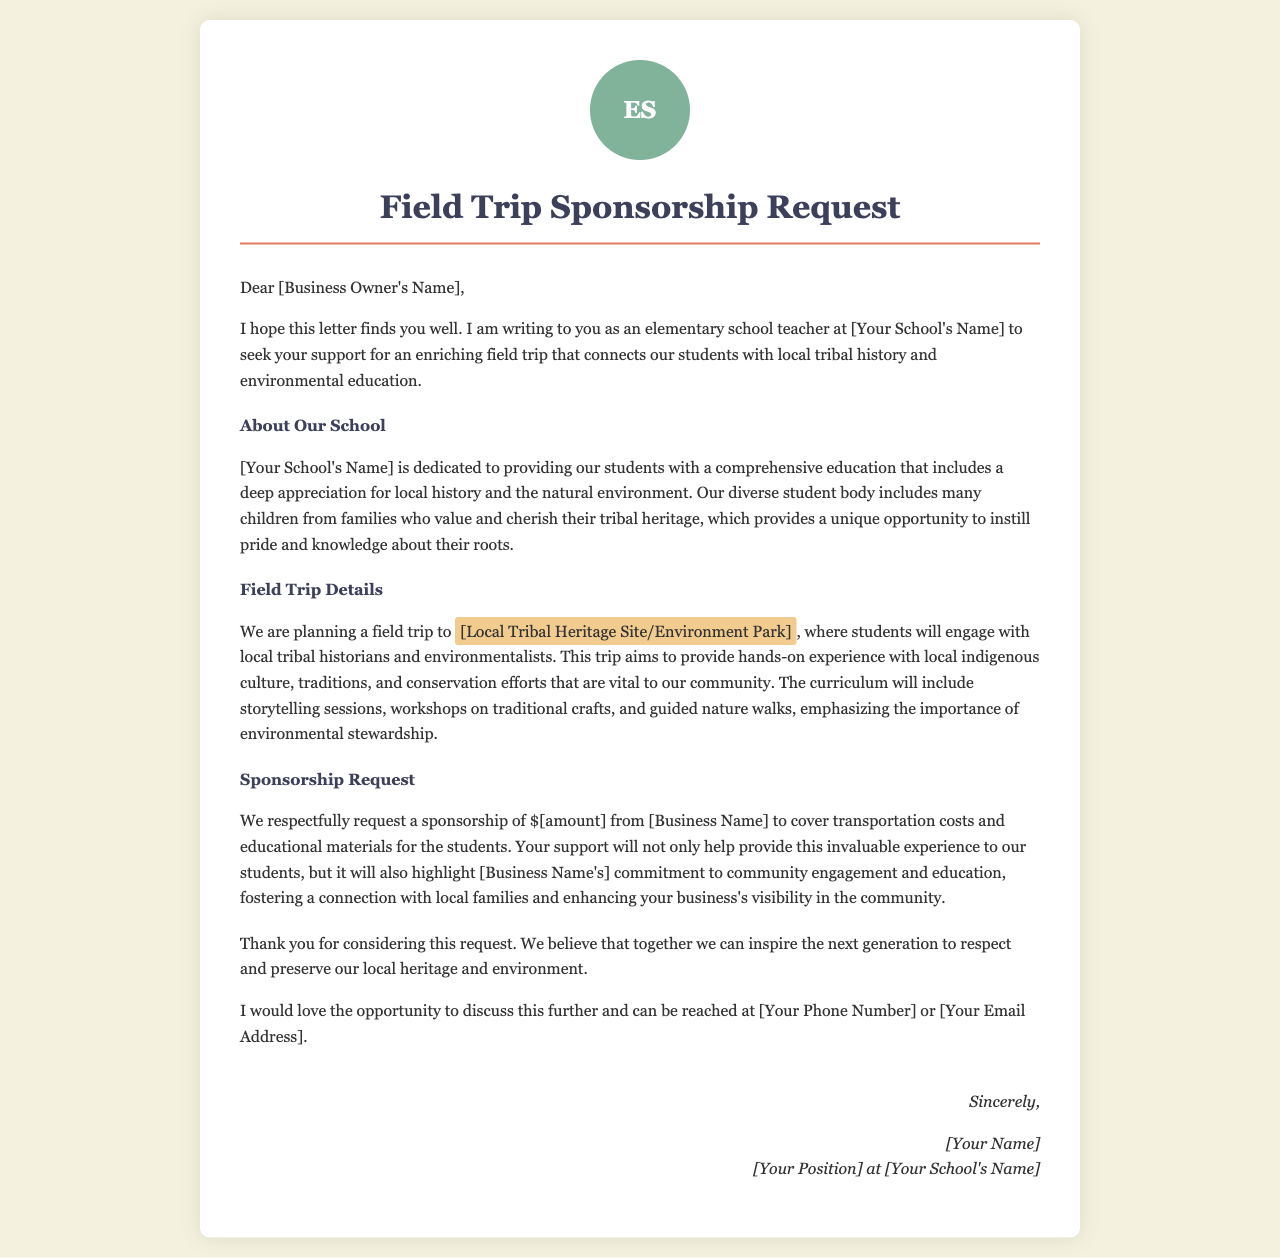what is the name of the school? The school mentioned in the document is referred to as [Your School's Name], which represents a placeholder for the actual name.
Answer: [Your School's Name] who is the letter addressed to? The letter is addressed to [Business Owner's Name], which is a placeholder for the actual name of the business owner.
Answer: [Business Owner's Name] what is the purpose of the field trip? The purpose of the field trip is to connect students with local tribal history and environmental education.
Answer: local tribal history and environmental education where will the field trip take place? The field trip will take place at [Local Tribal Heritage Site/Environment Park], which serves as a placeholder for the actual location.
Answer: [Local Tribal Heritage Site/Environment Park] how much sponsorship is being requested? The letter requests a sponsorship of $[amount], which is a placeholder for the specific amount needed.
Answer: $[amount] what activities will students engage in during the field trip? Students will engage in storytelling sessions, workshops on traditional crafts, and guided nature walks.
Answer: storytelling sessions, workshops on traditional crafts, guided nature walks what is emphasized in the curriculum of the field trip? The curriculum emphasizes the importance of environmental stewardship.
Answer: environmental stewardship what role does the business's support play in community relations? The support will highlight [Business Name's] commitment to community engagement and education.
Answer: community engagement and education how can the letter writer be contacted for further discussion? The letter writer can be contacted at [Your Phone Number] or [Your Email Address], which are placeholders for the actual details.
Answer: [Your Phone Number] or [Your Email Address] 